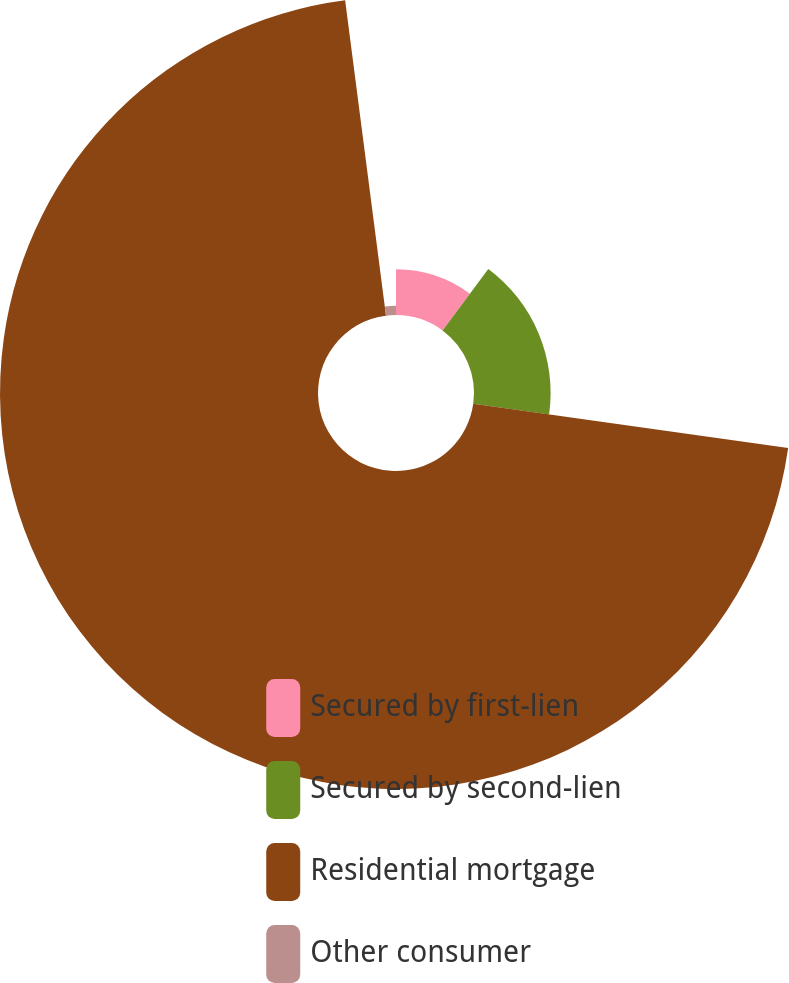Convert chart to OTSL. <chart><loc_0><loc_0><loc_500><loc_500><pie_chart><fcel>Secured by first-lien<fcel>Secured by second-lien<fcel>Residential mortgage<fcel>Other consumer<nl><fcel>10.18%<fcel>17.04%<fcel>70.73%<fcel>2.05%<nl></chart> 